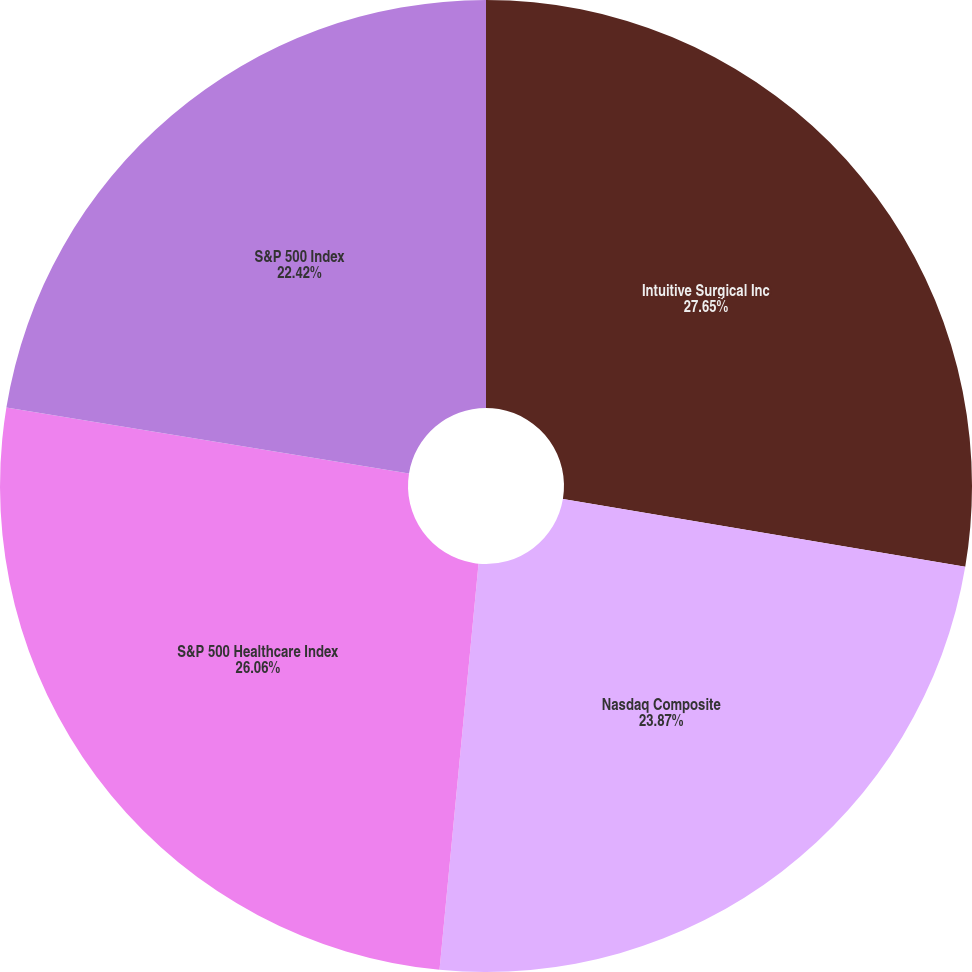<chart> <loc_0><loc_0><loc_500><loc_500><pie_chart><fcel>Intuitive Surgical Inc<fcel>Nasdaq Composite<fcel>S&P 500 Healthcare Index<fcel>S&P 500 Index<nl><fcel>27.66%<fcel>23.87%<fcel>26.06%<fcel>22.42%<nl></chart> 